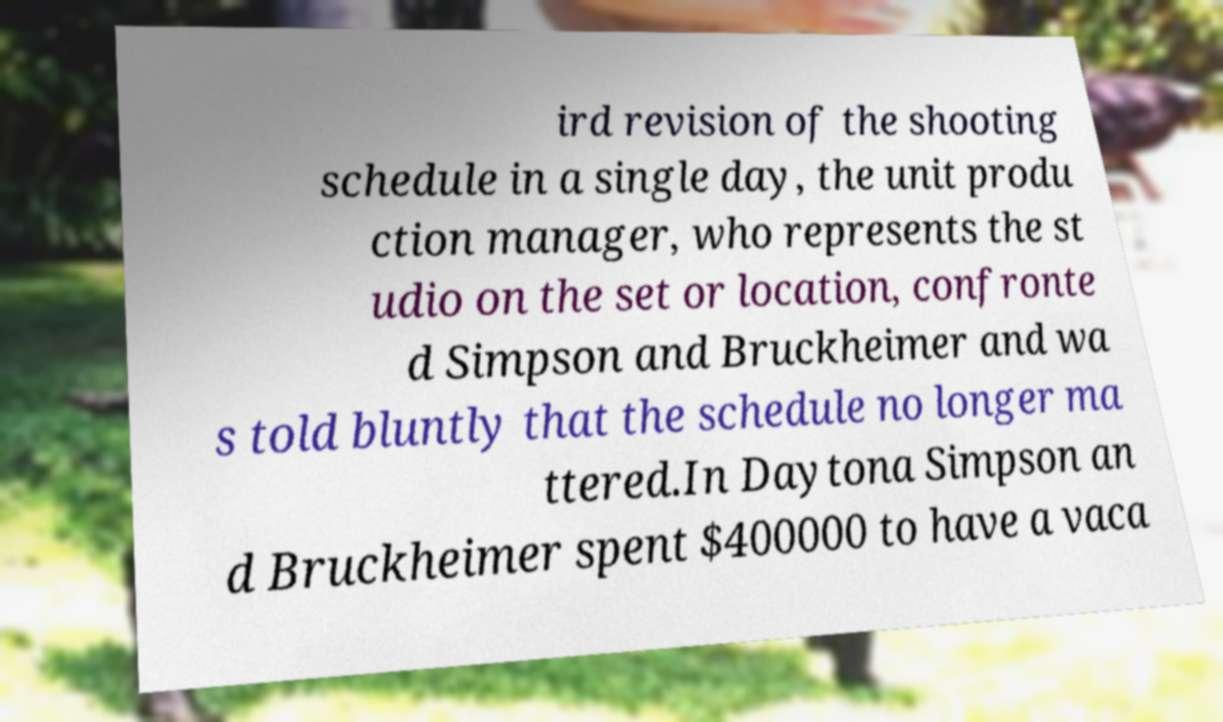Could you extract and type out the text from this image? ird revision of the shooting schedule in a single day, the unit produ ction manager, who represents the st udio on the set or location, confronte d Simpson and Bruckheimer and wa s told bluntly that the schedule no longer ma ttered.In Daytona Simpson an d Bruckheimer spent $400000 to have a vaca 